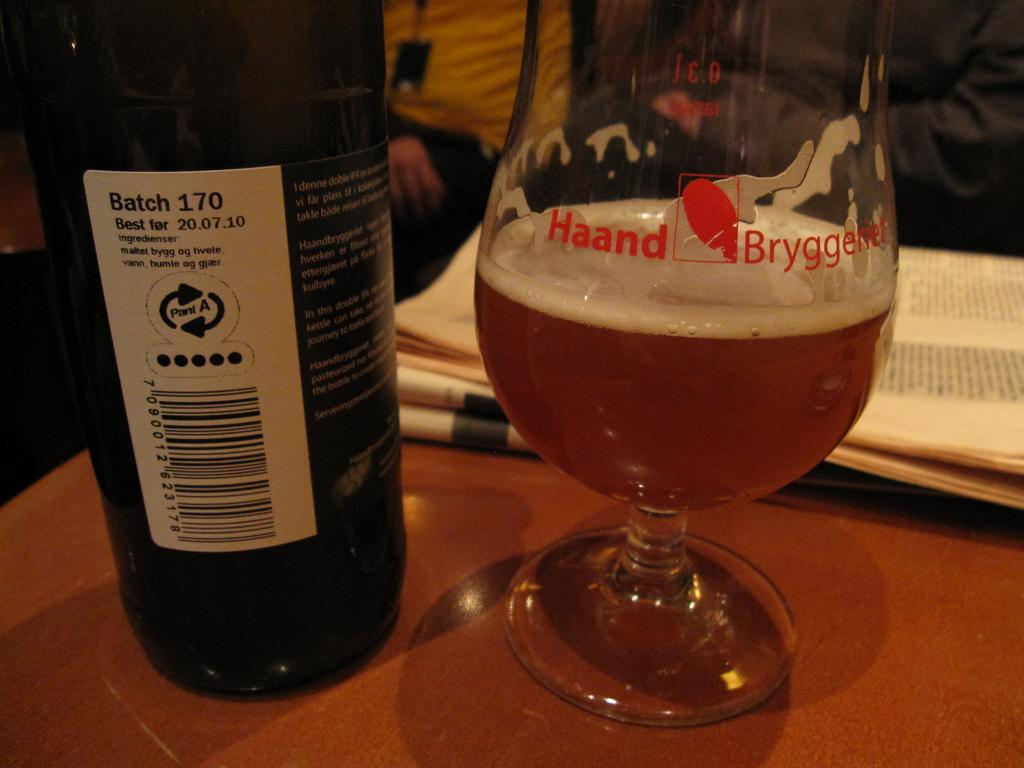What piece of furniture is present in the image? There is a table in the image. What object can be seen on the table? There is a bottle glass and a paper on the table. Can you describe the people in the background? There are two persons sitting in the background, and they are sitting on chairs. What type of battle is taking place in the image? There is no battle present in the image; it features a table with objects and two persons sitting in the background. Can you describe the harbor in the image? There is no harbor present in the image; it features a table with objects and two persons sitting in the background. 